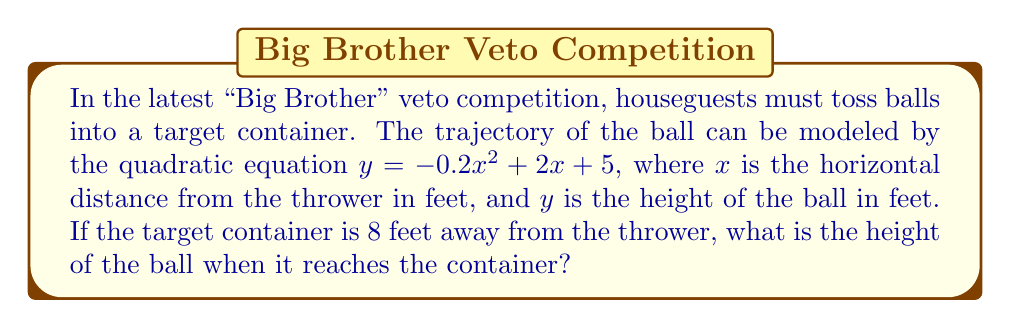Could you help me with this problem? To solve this problem, we need to follow these steps:

1. We have the quadratic equation: $y = -0.2x^2 + 2x + 5$

2. We know that the target container is 8 feet away, so we need to find $y$ when $x = 8$

3. Let's substitute $x = 8$ into our equation:

   $y = -0.2(8)^2 + 2(8) + 5$

4. Now, let's calculate step by step:
   
   $y = -0.2(64) + 16 + 5$
   
   $y = -12.8 + 16 + 5$
   
   $y = 3.2 + 5$
   
   $y = 8.2$

5. Therefore, when the ball reaches the target container 8 feet away, it will be at a height of 8.2 feet.
Answer: 8.2 feet 